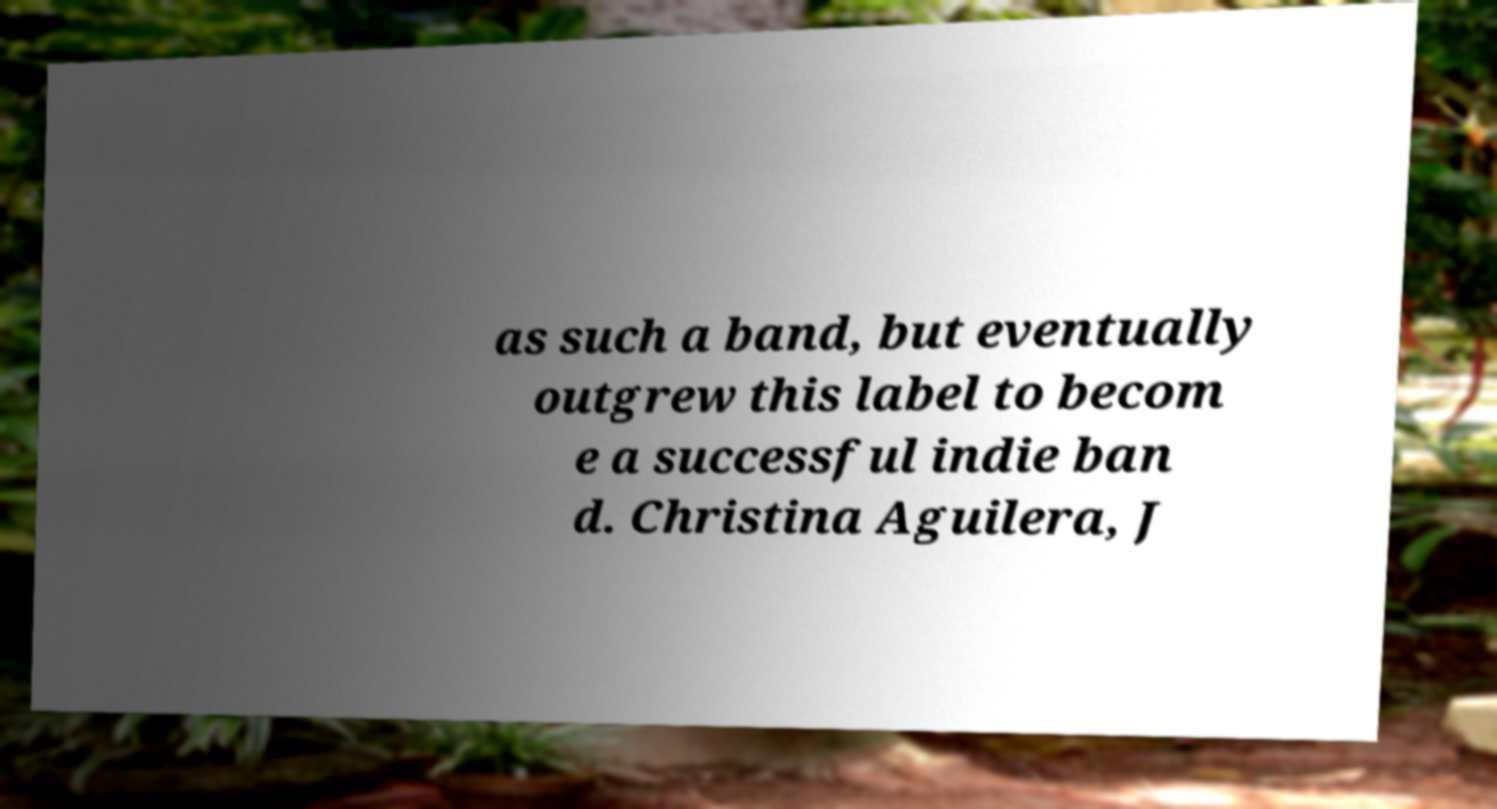Can you accurately transcribe the text from the provided image for me? as such a band, but eventually outgrew this label to becom e a successful indie ban d. Christina Aguilera, J 